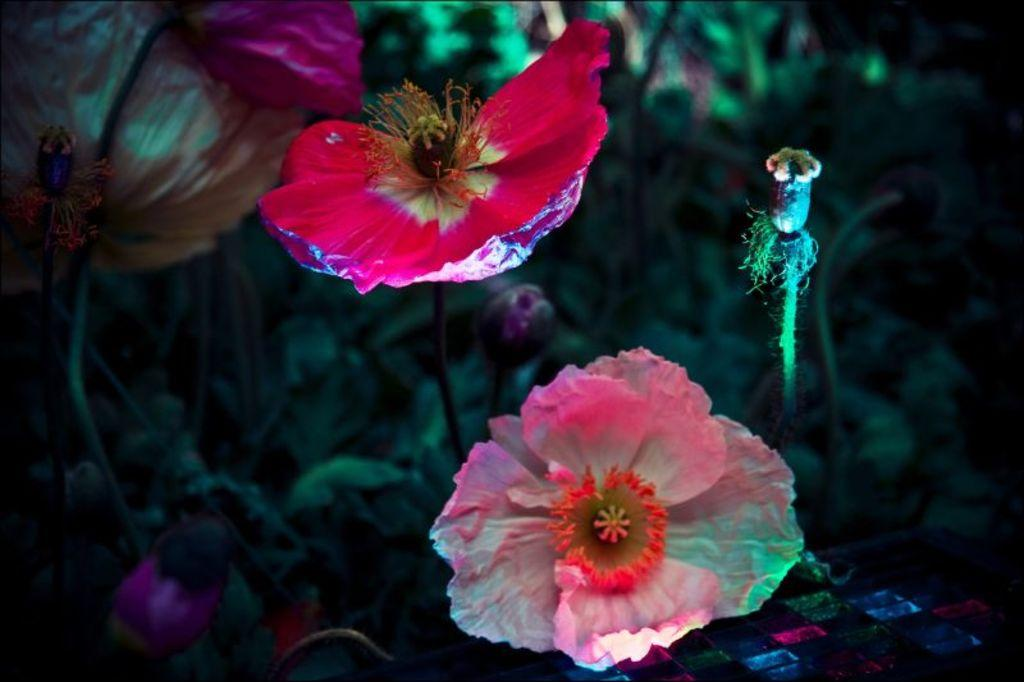What types of living organisms are present in the image? The image contains flowers and plants. What color are the flowers in the image? The flowers in the image are red in color. What type of development is taking place in the image? There is no development or construction activity present in the image; it features flowers and plants. What type of quilt can be seen in the image? There is no quilt present in the image; it features flowers and plants. 